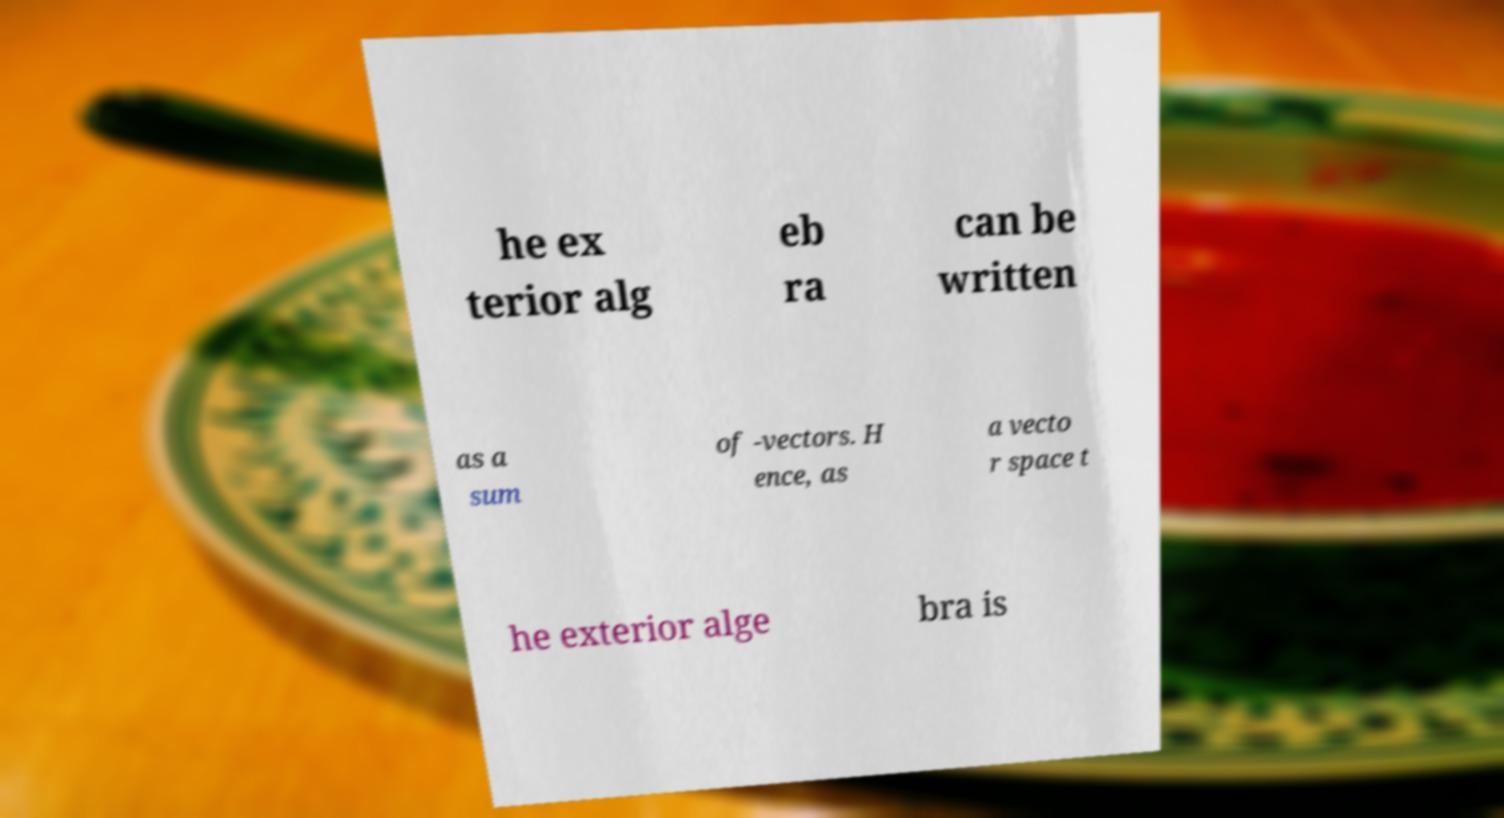Could you assist in decoding the text presented in this image and type it out clearly? he ex terior alg eb ra can be written as a sum of -vectors. H ence, as a vecto r space t he exterior alge bra is 